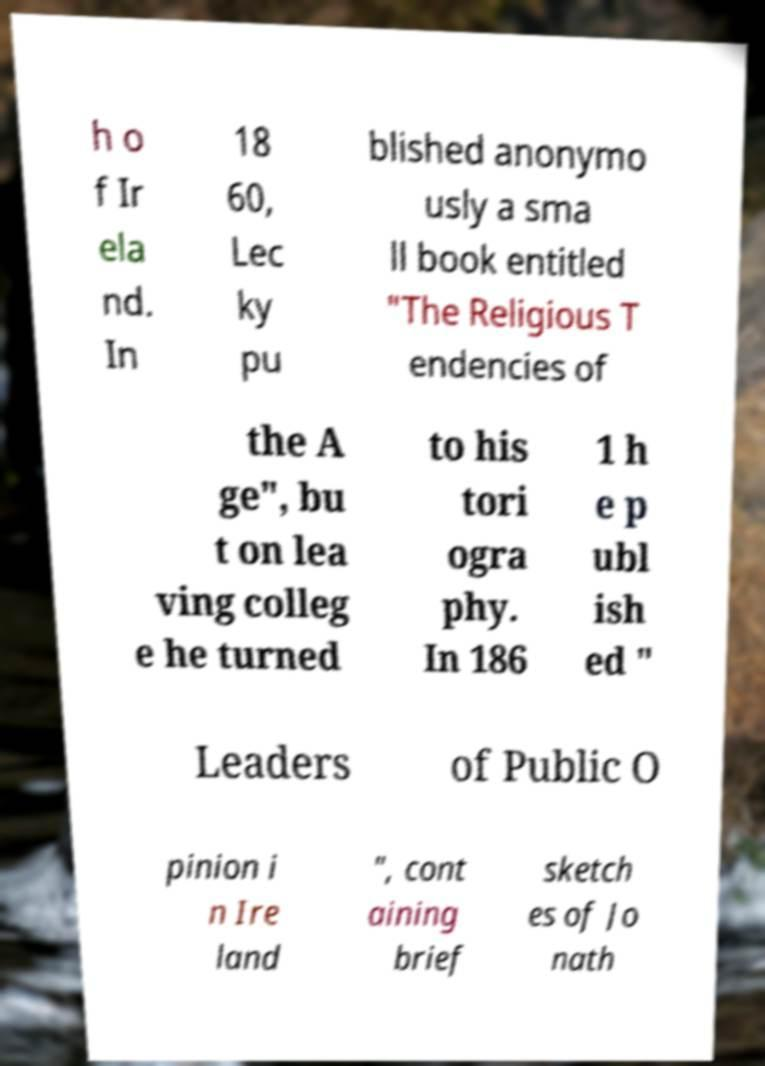Can you read and provide the text displayed in the image?This photo seems to have some interesting text. Can you extract and type it out for me? h o f Ir ela nd. In 18 60, Lec ky pu blished anonymo usly a sma ll book entitled "The Religious T endencies of the A ge", bu t on lea ving colleg e he turned to his tori ogra phy. In 186 1 h e p ubl ish ed " Leaders of Public O pinion i n Ire land ", cont aining brief sketch es of Jo nath 